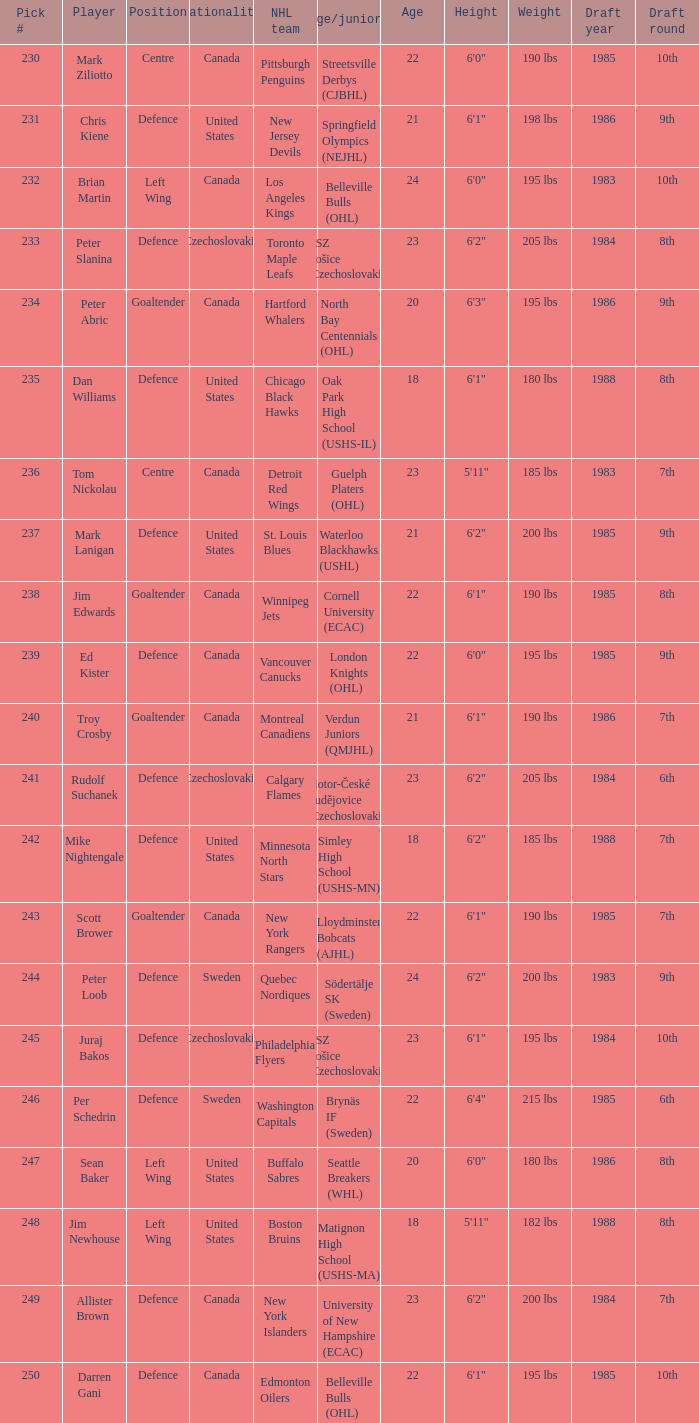List the players for team brynäs if (sweden). Per Schedrin. 